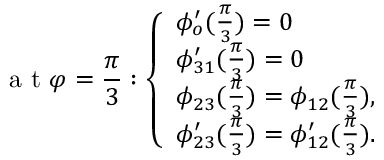Convert formula to latex. <formula><loc_0><loc_0><loc_500><loc_500>a t \varphi = \frac { \pi } { 3 } \colon \left \{ \begin{array} { l l } { \phi _ { o } ^ { \prime } ( \frac { \pi } { 3 } ) = 0 } \\ { \phi _ { 3 1 } ^ { \prime } ( \frac { \pi } { 3 } ) = 0 } \\ { \phi _ { 2 3 } ( \frac { \pi } { 3 } ) = \phi _ { 1 2 } ( \frac { \pi } { 3 } ) , } \\ { \phi _ { 2 3 } ^ { \prime } ( \frac { \pi } { 3 } ) = \phi _ { 1 2 } ^ { \prime } ( \frac { \pi } { 3 } ) . } \end{array}</formula> 